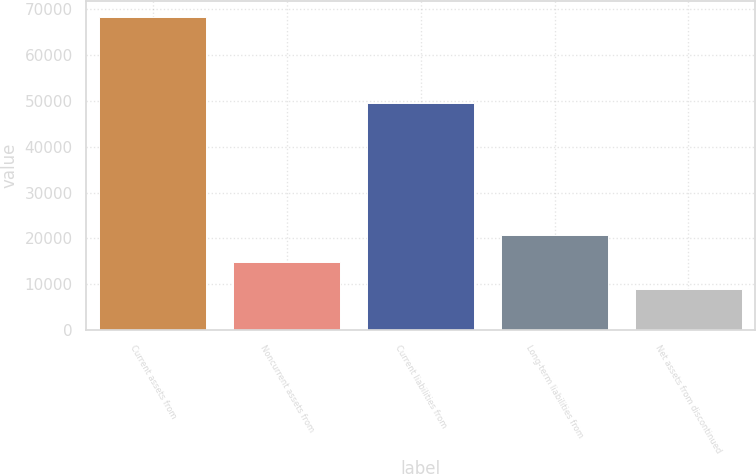<chart> <loc_0><loc_0><loc_500><loc_500><bar_chart><fcel>Current assets from<fcel>Noncurrent assets from<fcel>Current liabilities from<fcel>Long-term liabilities from<fcel>Net assets from discontinued<nl><fcel>68239<fcel>14860<fcel>49471<fcel>20791<fcel>8929<nl></chart> 